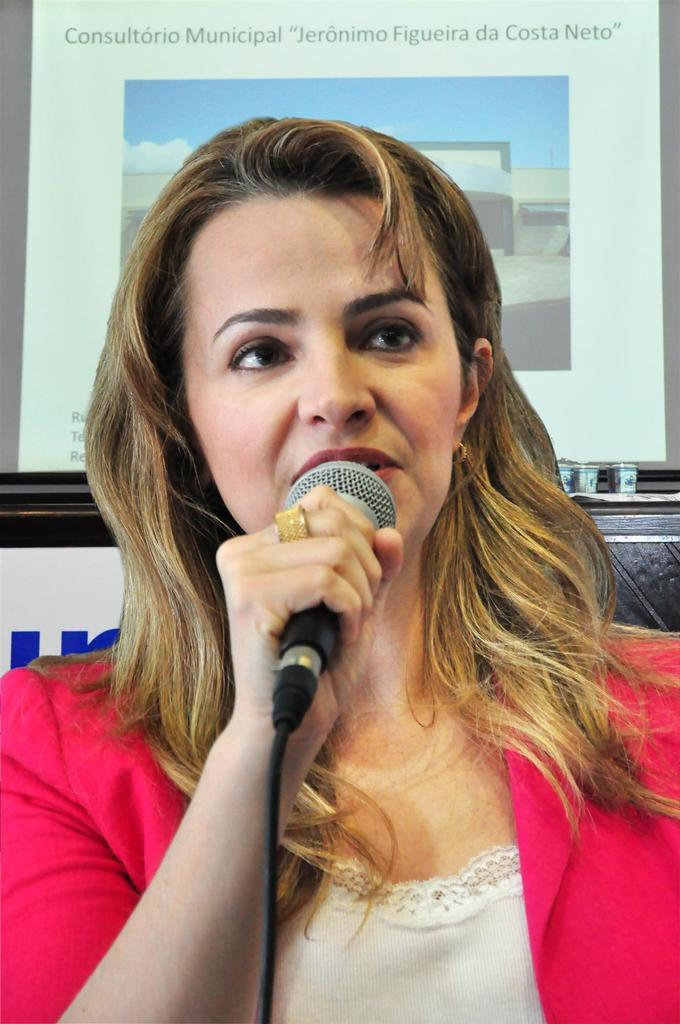Who is the main subject in the image? There is a woman in the image. What is the woman holding in the image? The woman is holding a mic. What type of account does the woman need to access in the image? There is no mention of an account or any need for access in the image; the woman is simply holding a mic. 